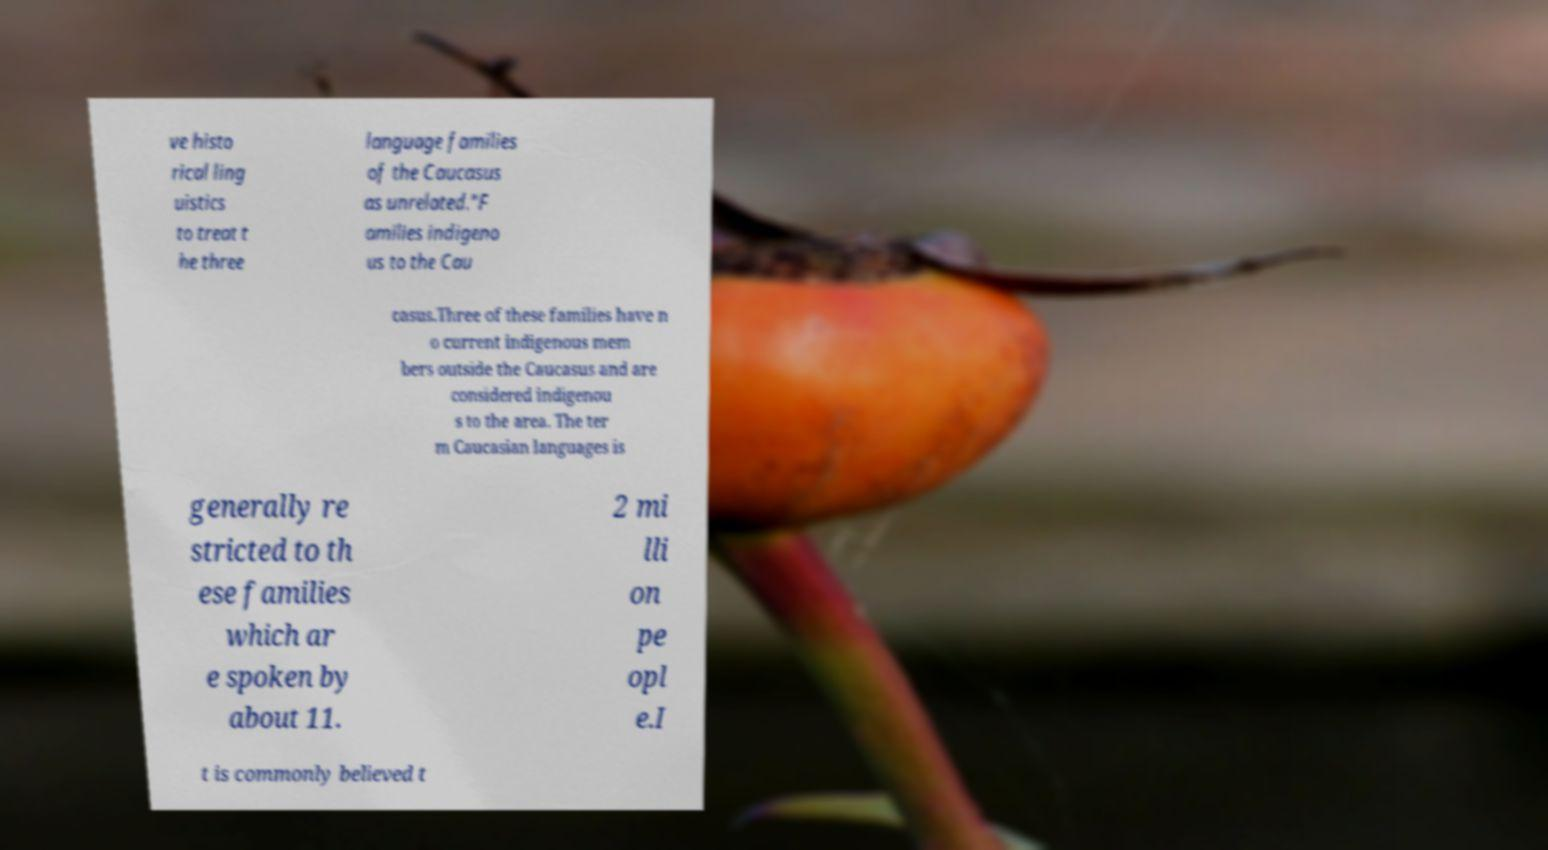Could you assist in decoding the text presented in this image and type it out clearly? ve histo rical ling uistics to treat t he three language families of the Caucasus as unrelated."F amilies indigeno us to the Cau casus.Three of these families have n o current indigenous mem bers outside the Caucasus and are considered indigenou s to the area. The ter m Caucasian languages is generally re stricted to th ese families which ar e spoken by about 11. 2 mi lli on pe opl e.I t is commonly believed t 